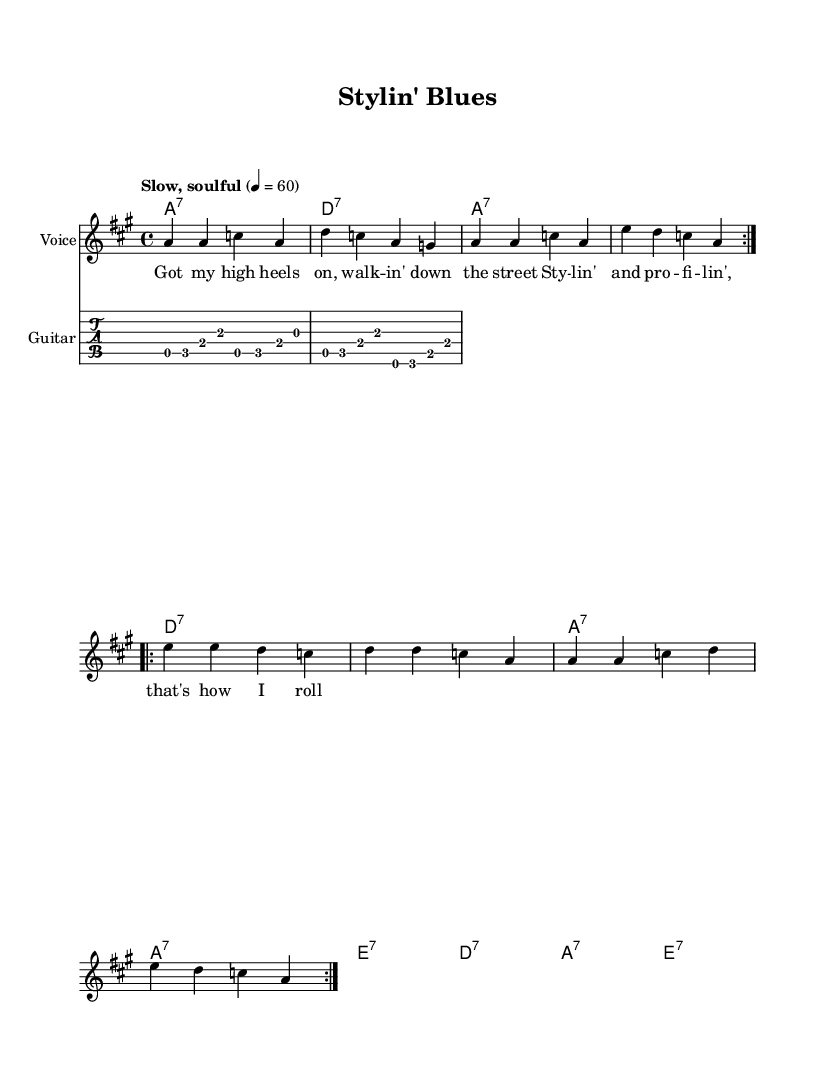What is the key signature of this music? The key signature is A major, indicated by three sharps (F#, C#, and G#) shown at the beginning of the score.
Answer: A major What is the time signature of this music? The time signature is 4/4, which can be seen at the beginning of the score, indicating four beats per measure.
Answer: 4/4 What tempo is indicated for this piece? The tempo is described as "Slow, soulful," which sets the mood for how the piece should be played.
Answer: Slow, soulful How many times is the first section of the melody repeated? The first section of the melody is repeated twice, as indicated by the "repeat volta 2" marking.
Answer: Twice What type of chord is predominantly used in the harmonies? The predominant chord type used in the harmonies is the seventh chord, as seen with the chord notations (like A:7, D:7).
Answer: Seventh chord How many measures are in the first part before it repeats? The first part consists of four measures, which can be counted directly from the melody section before it repeats.
Answer: Four measures What thematic element does the lyrics primarily convey? The thematic element conveyed in the lyrics is self-expression and style, evident in phrases celebrating confidence and identity expressed through fashion.
Answer: Self-expression and style 